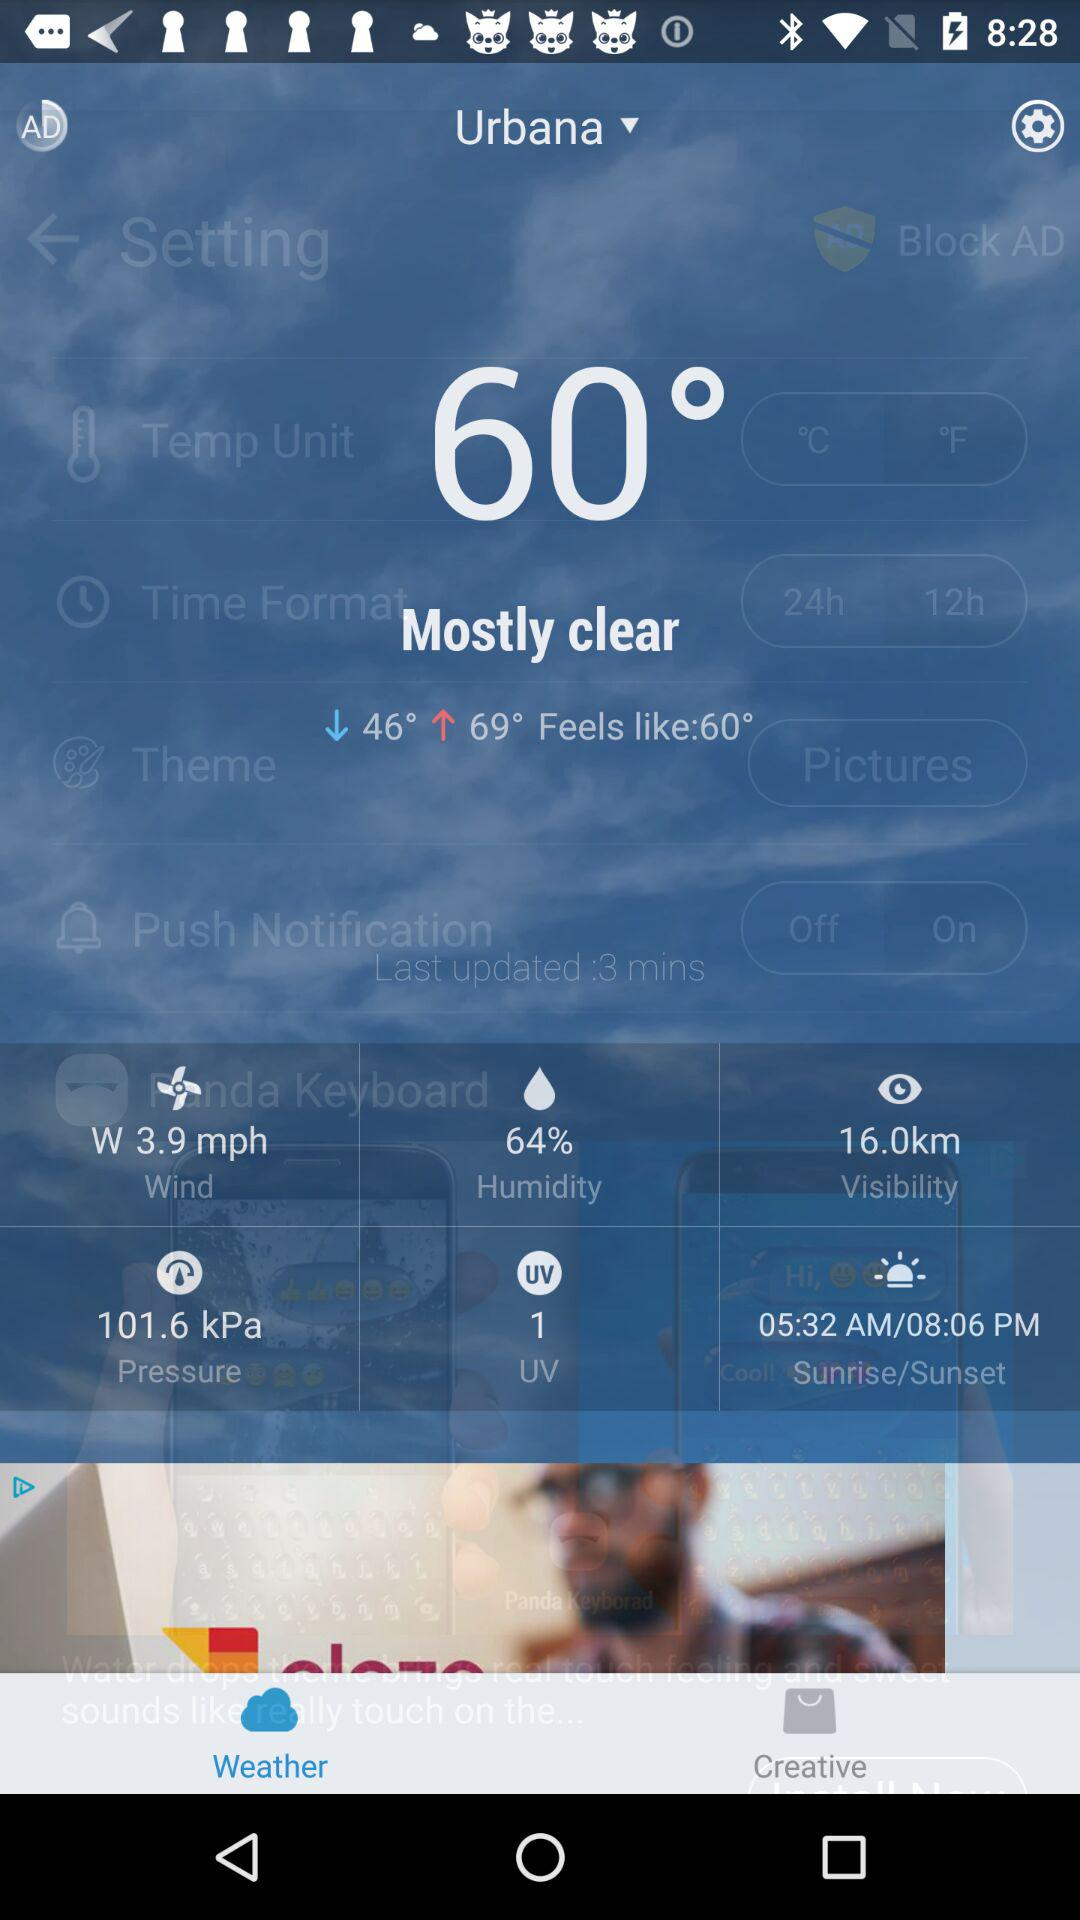How many minutes ago was the push notification updated?
Answer the question using a single word or phrase. 3 